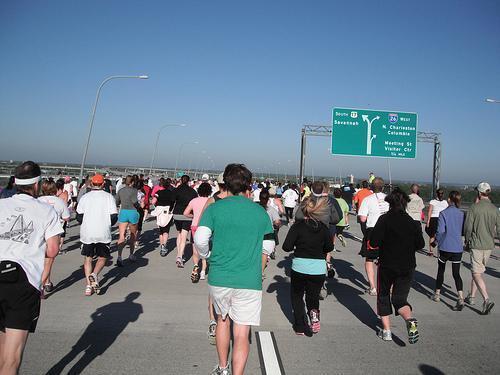How many street signs are shown?
Give a very brief answer. 1. 